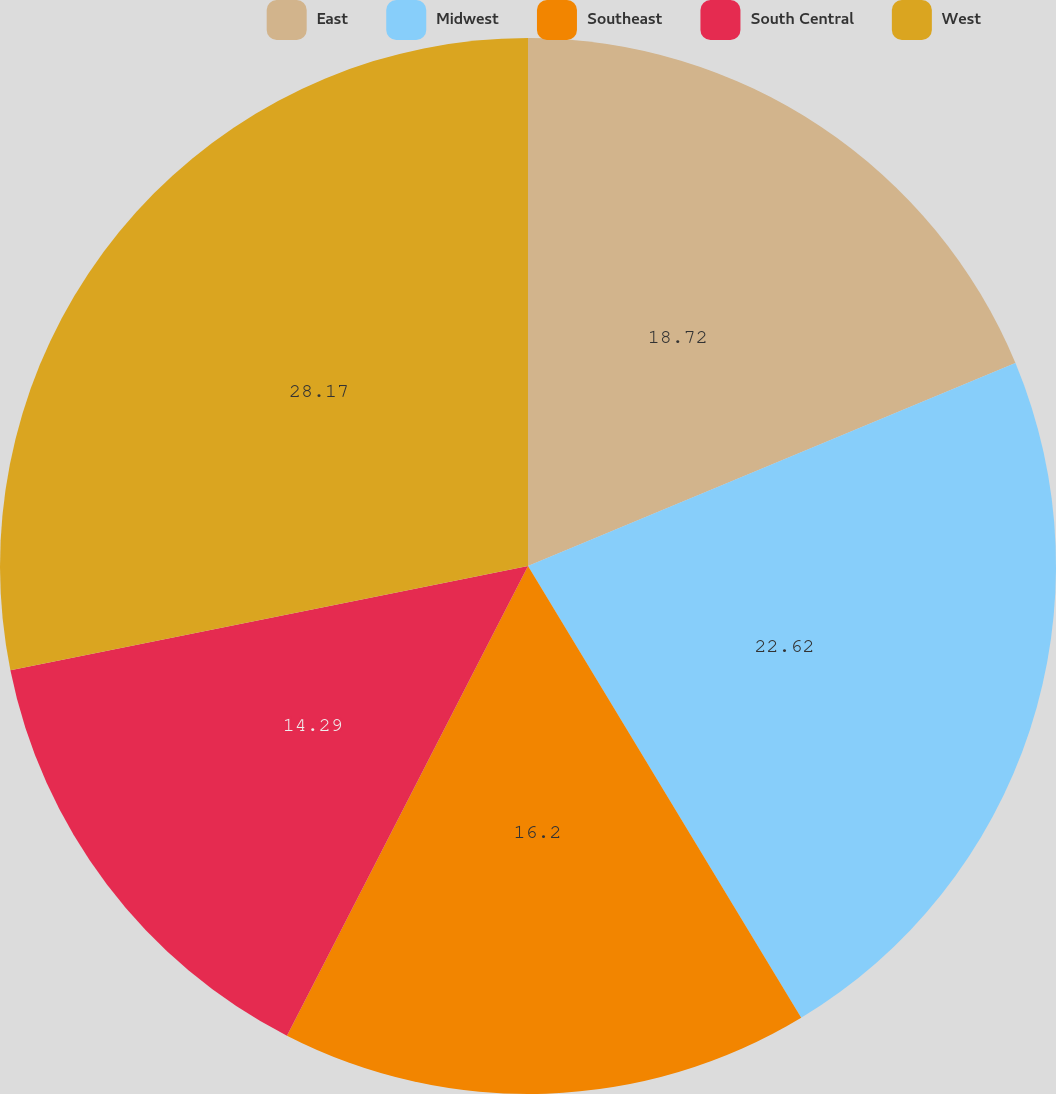Convert chart to OTSL. <chart><loc_0><loc_0><loc_500><loc_500><pie_chart><fcel>East<fcel>Midwest<fcel>Southeast<fcel>South Central<fcel>West<nl><fcel>18.72%<fcel>22.62%<fcel>16.2%<fcel>14.29%<fcel>28.16%<nl></chart> 